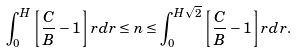<formula> <loc_0><loc_0><loc_500><loc_500>\int _ { 0 } ^ { H } \left [ \frac { C } { B } - 1 \right ] r d r \leq n \leq \int _ { 0 } ^ { H \sqrt { 2 } } \left [ \frac { C } { B } - 1 \right ] r d r .</formula> 